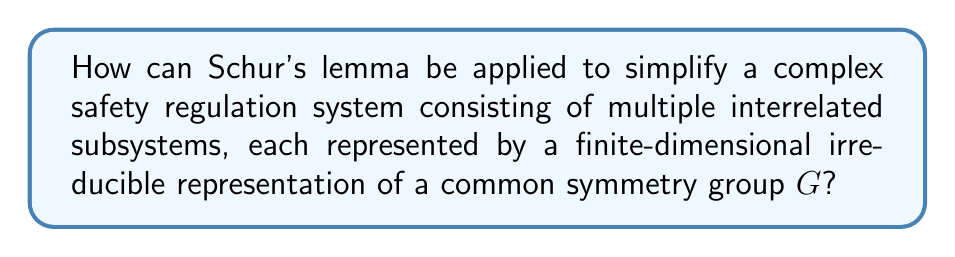Give your solution to this math problem. To apply Schur's lemma to simplify a complex safety regulation system, we can follow these steps:

1. Identify the symmetry group $G$ that represents the common structure across all subsystems in the safety regulation framework.

2. Represent each subsystem as a finite-dimensional irreducible representation of $G$, denoted as $V_i$ for the $i$-th subsystem.

3. Consider the interrelations between subsystems as $G$-equivariant maps $\phi_{ij}: V_i \to V_j$.

4. Apply Schur's lemma, which states:
   If $V_i$ and $V_j$ are non-isomorphic irreducible representations, then $\phi_{ij} = 0$.
   If $V_i$ and $V_j$ are isomorphic irreducible representations, then $\phi_{ij}$ is either 0 or a scalar multiple of the identity map.

5. Simplify the system by:
   a) Eliminating all zero maps between non-isomorphic representations.
   b) Reducing isomorphic representation interactions to scalar multiples.

6. The resulting simplified system will have:
   $$\text{Simplified System} = \bigoplus_{k=1}^n m_k V_k$$
   Where $V_k$ are the distinct irreducible representations and $m_k$ their multiplicities.

7. Safety regulations can now focus on:
   a) Individual irreducible representations $V_k$ (subsystem-specific rules).
   b) Scalar interactions between isomorphic copies (simplified inter-subsystem regulations).

This approach significantly reduces the complexity of the safety regulation system while preserving its essential structure and symmetries.
Answer: $$\text{Simplified System} = \bigoplus_{k=1}^n m_k V_k$$ 